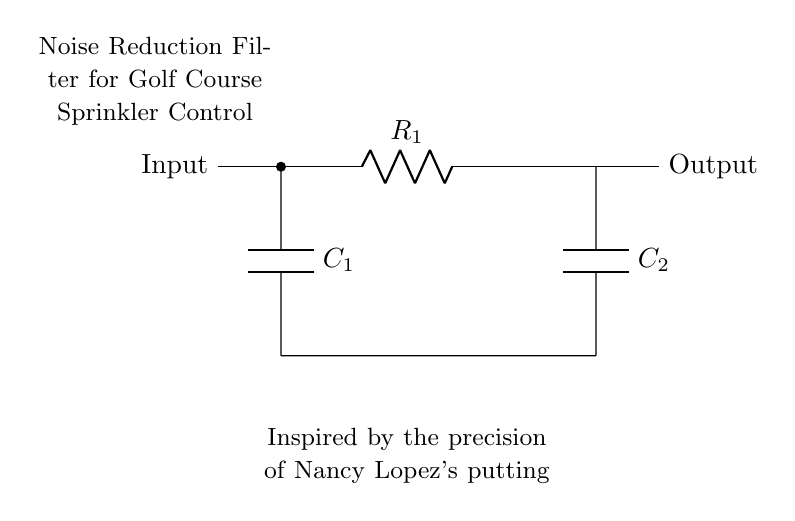What component is used to filter noise in this circuit? The circuit shows two capacitors, C1 and C2, which are commonly used to filter noise in electronic circuits. Capacitor C1 connects to the input, and C2 connects to the output, indicating their role in this noise reduction filter.
Answer: Capacitors What is the value of resistor R1 in the circuit? The rendered circuit diagram does not specify a numerical value for resistor R1, so the answer is based on visual observation. It is labeled R1, but no value is given.
Answer: R1 How does the circuit reduce noise? The circuit uses capacitors to smooth out fluctuations in the voltage, effectively filtering out noise. When the noisy voltage enters the circuit, the capacitors charge and discharge, thereby filtering the signals and reducing noise.
Answer: By using capacitors What is the overall function of this circuit? The diagram indicates that it is a noise reduction filter specifically designed for golf course sprinkler control systems. The components work to filter out unwanted electrical noise, allowing for precise control of sprinkler systems.
Answer: Noise reduction filter How many capacitors are present in this circuit? The circuit diagram clearly shows two capacitors labeled C1 and C2. The presence of both capacitors is for better noise filtering efficiency.
Answer: Two Why is this circuit inspired by Nancy Lopez? The note in the circuit refers to Nancy Lopez, a famous golfer known for her precision. The mention likely indicates that the design aims to achieve a high level of performance and accuracy in controlling the sprinkler system, similar to her putting skills.
Answer: Precision and performance 